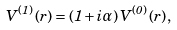Convert formula to latex. <formula><loc_0><loc_0><loc_500><loc_500>V ^ { ( 1 ) } \left ( r \right ) = \left ( { 1 + i \alpha } \right ) V ^ { ( 0 ) } \left ( r \right ) ,</formula> 